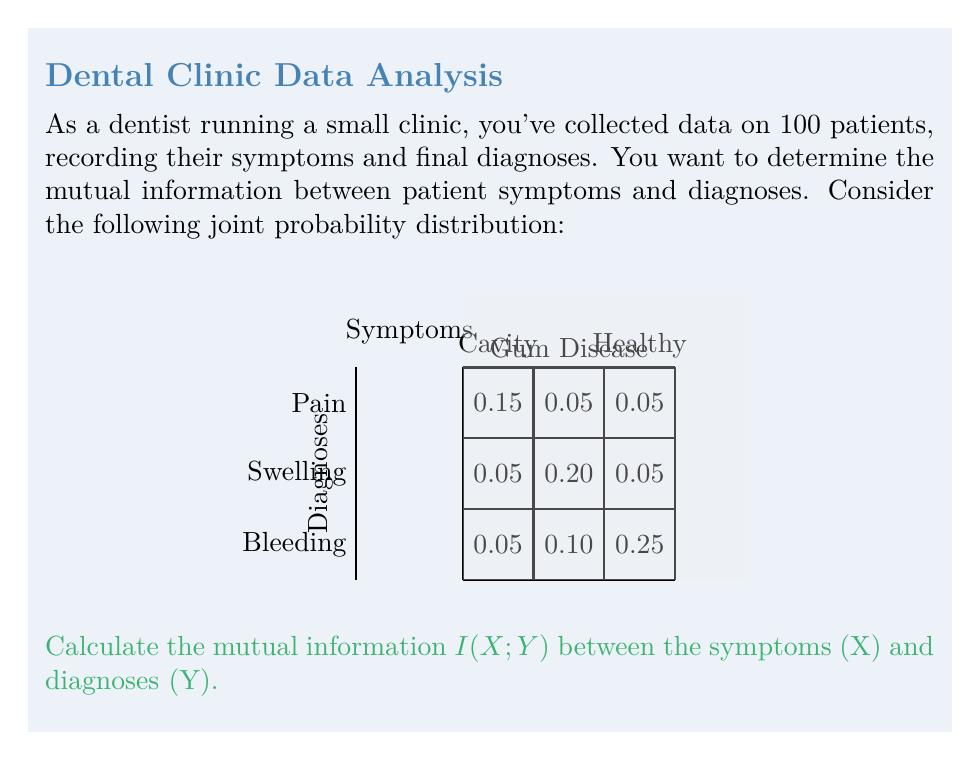Show me your answer to this math problem. To calculate the mutual information $I(X;Y)$, we'll follow these steps:

1) First, calculate the marginal probabilities:
   P(X = Pain) = 0.15 + 0.05 + 0.05 = 0.25
   P(X = Swelling) = 0.05 + 0.20 + 0.05 = 0.30
   P(X = Bleeding) = 0.05 + 0.10 + 0.25 = 0.40
   P(Y = Cavity) = 0.15 + 0.05 + 0.05 = 0.25
   P(Y = Gum Disease) = 0.05 + 0.20 + 0.10 = 0.35
   P(Y = Healthy) = 0.05 + 0.05 + 0.25 = 0.35

2) The mutual information is defined as:
   $$I(X;Y) = \sum_{x \in X} \sum_{y \in Y} P(x,y) \log_2 \frac{P(x,y)}{P(x)P(y)}$$

3) Calculate each term:
   0.15 * log2(0.15 / (0.25 * 0.25)) = 0.1122
   0.05 * log2(0.05 / (0.25 * 0.35)) = 0.0073
   0.05 * log2(0.05 / (0.25 * 0.35)) = 0.0073
   0.05 * log2(0.05 / (0.30 * 0.25)) = 0.0031
   0.20 * log2(0.20 / (0.30 * 0.35)) = 0.1187
   0.05 * log2(0.05 / (0.30 * 0.35)) = 0.0031
   0.05 * log2(0.05 / (0.40 * 0.25)) = 0.0000
   0.10 * log2(0.10 / (0.40 * 0.35)) = 0.0163
   0.25 * log2(0.25 / (0.40 * 0.35)) = 0.1887

4) Sum all terms:
   I(X;Y) = 0.1122 + 0.0073 + 0.0073 + 0.0031 + 0.1187 + 0.0031 + 0.0000 + 0.0163 + 0.1887 = 0.4567

Therefore, the mutual information I(X;Y) is approximately 0.4567 bits.
Answer: 0.4567 bits 